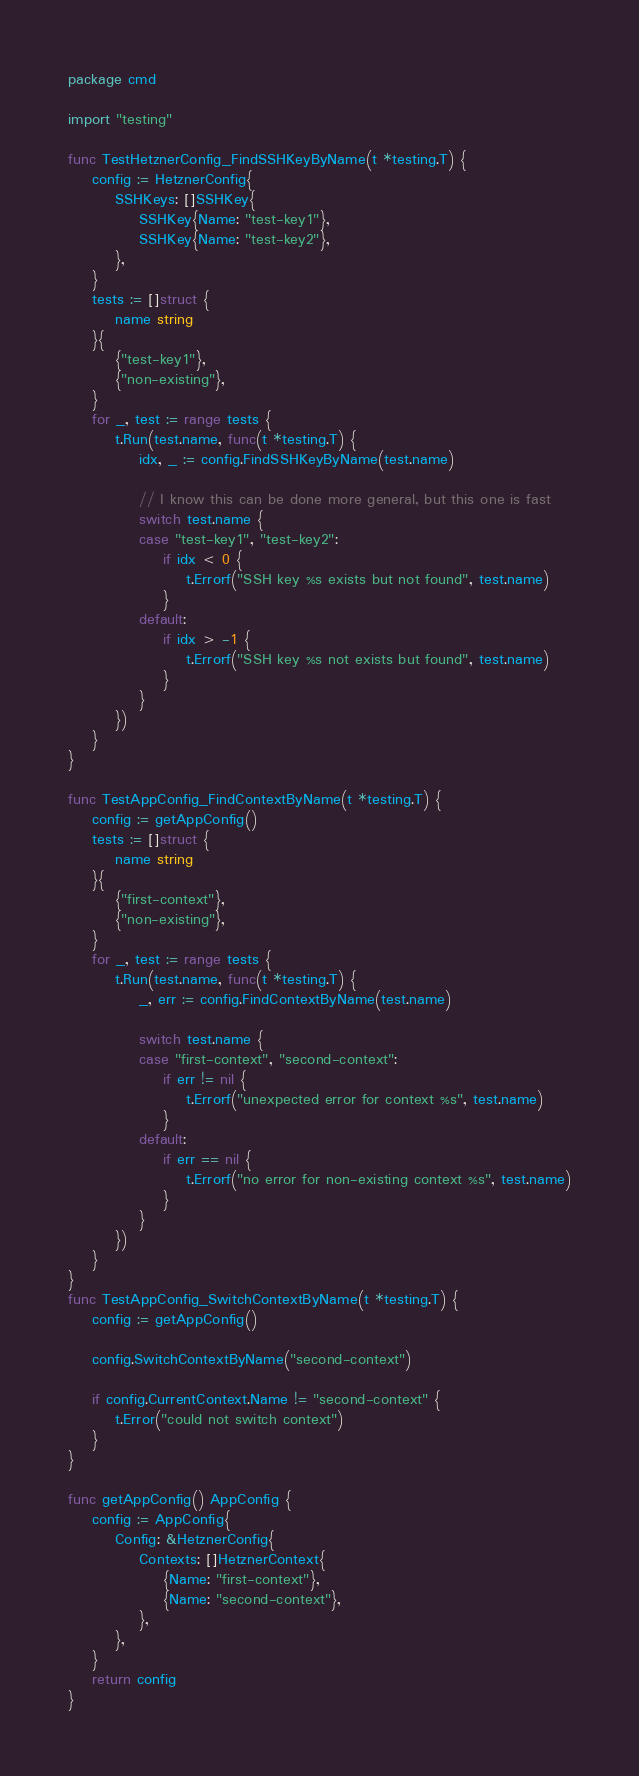<code> <loc_0><loc_0><loc_500><loc_500><_Go_>package cmd

import "testing"

func TestHetznerConfig_FindSSHKeyByName(t *testing.T) {
	config := HetznerConfig{
		SSHKeys: []SSHKey{
			SSHKey{Name: "test-key1"},
			SSHKey{Name: "test-key2"},
		},
	}
	tests := []struct {
		name string
	}{
		{"test-key1"},
		{"non-existing"},
	}
	for _, test := range tests {
		t.Run(test.name, func(t *testing.T) {
			idx, _ := config.FindSSHKeyByName(test.name)

			// I know this can be done more general, but this one is fast
			switch test.name {
			case "test-key1", "test-key2":
				if idx < 0 {
					t.Errorf("SSH key %s exists but not found", test.name)
				}
			default:
				if idx > -1 {
					t.Errorf("SSH key %s not exists but found", test.name)
				}
			}
		})
	}
}

func TestAppConfig_FindContextByName(t *testing.T) {
	config := getAppConfig()
	tests := []struct {
		name string
	}{
		{"first-context"},
		{"non-existing"},
	}
	for _, test := range tests {
		t.Run(test.name, func(t *testing.T) {
			_, err := config.FindContextByName(test.name)

			switch test.name {
			case "first-context", "second-context":
				if err != nil {
					t.Errorf("unexpected error for context %s", test.name)
				}
			default:
				if err == nil {
					t.Errorf("no error for non-existing context %s", test.name)
				}
			}
		})
	}
}
func TestAppConfig_SwitchContextByName(t *testing.T) {
	config := getAppConfig()

	config.SwitchContextByName("second-context")

	if config.CurrentContext.Name != "second-context" {
		t.Error("could not switch context")
	}
}

func getAppConfig() AppConfig {
	config := AppConfig{
		Config: &HetznerConfig{
			Contexts: []HetznerContext{
				{Name: "first-context"},
				{Name: "second-context"},
			},
		},
	}
	return config
}
</code> 